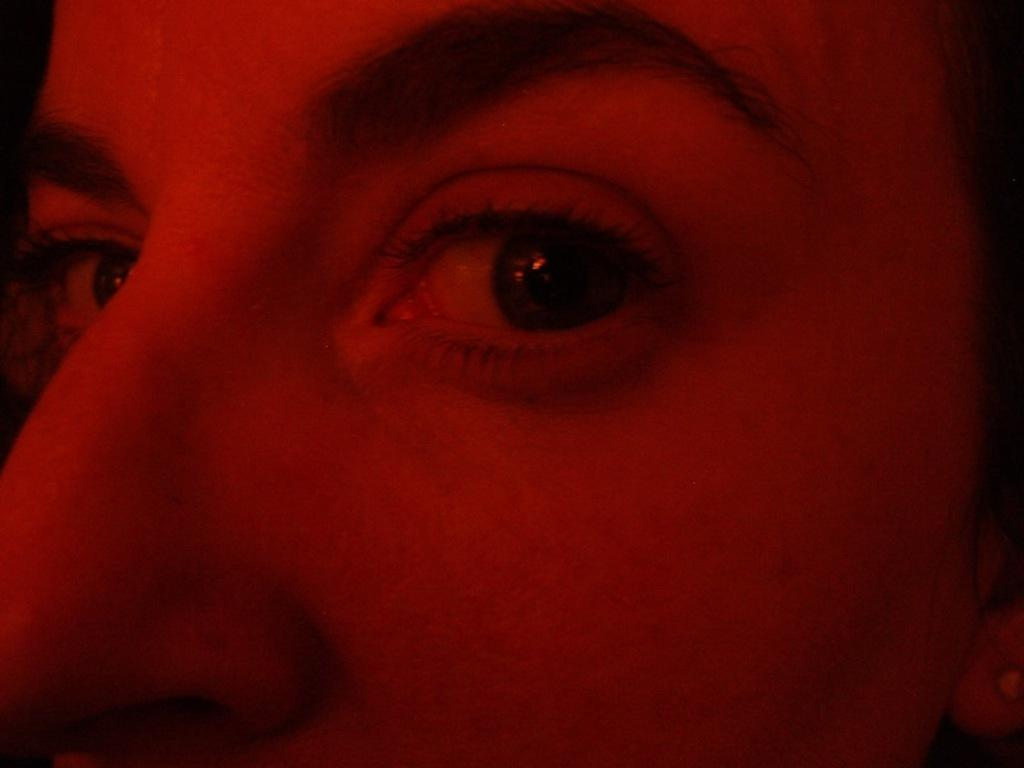What is the main subject of the image? There is a close view of a person in the image. What type of education does the person's stomach have in the image? There is no mention of education or the person's stomach in the image, as it only shows a close view of a person. 